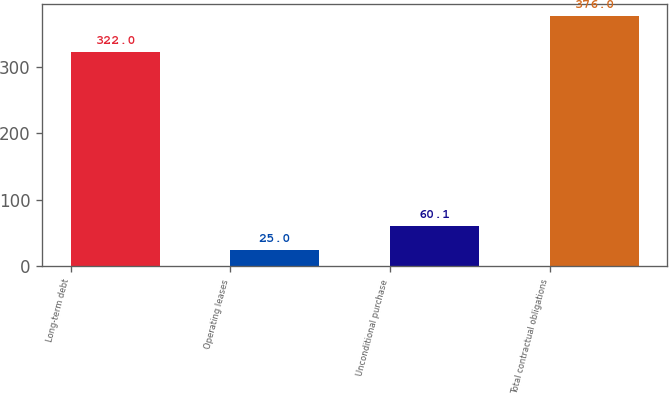Convert chart to OTSL. <chart><loc_0><loc_0><loc_500><loc_500><bar_chart><fcel>Long-term debt<fcel>Operating leases<fcel>Unconditional purchase<fcel>Total contractual obligations<nl><fcel>322<fcel>25<fcel>60.1<fcel>376<nl></chart> 